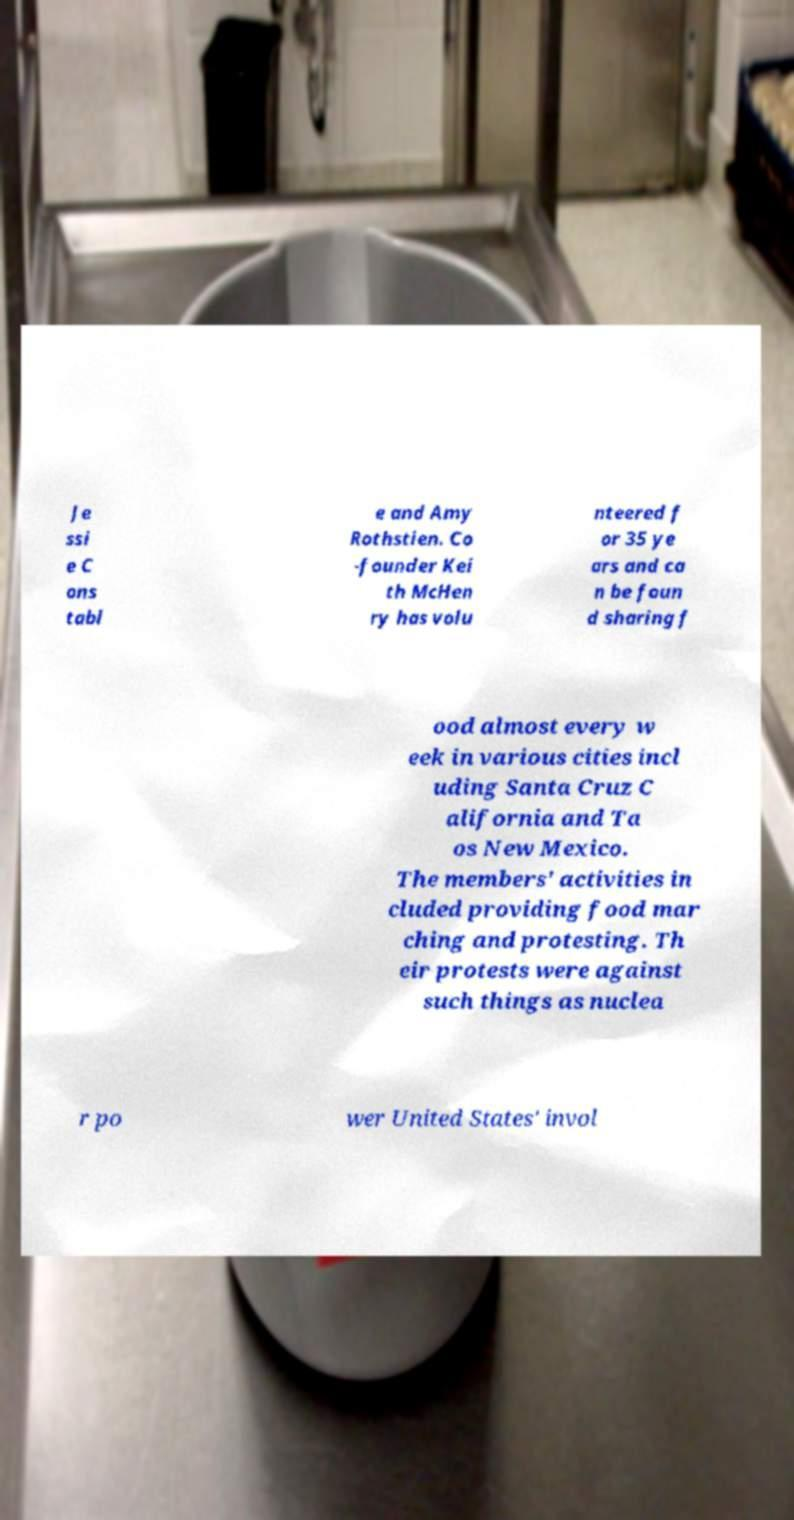What messages or text are displayed in this image? I need them in a readable, typed format. Je ssi e C ons tabl e and Amy Rothstien. Co -founder Kei th McHen ry has volu nteered f or 35 ye ars and ca n be foun d sharing f ood almost every w eek in various cities incl uding Santa Cruz C alifornia and Ta os New Mexico. The members' activities in cluded providing food mar ching and protesting. Th eir protests were against such things as nuclea r po wer United States' invol 